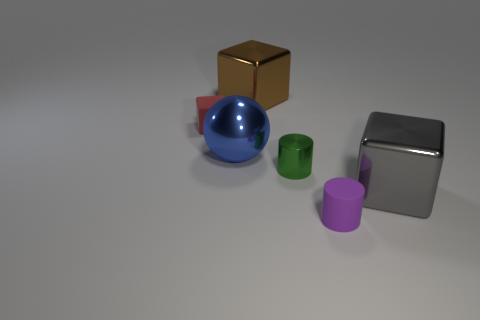How many other things are the same material as the tiny purple cylinder?
Keep it short and to the point. 1. The green shiny cylinder has what size?
Give a very brief answer. Small. Is there a big gray thing that has the same shape as the brown metallic object?
Keep it short and to the point. Yes. What number of objects are either blue shiny spheres or matte things behind the large gray cube?
Keep it short and to the point. 2. There is a big block behind the tiny block; what color is it?
Offer a terse response. Brown. Is the size of the cylinder that is on the left side of the small purple cylinder the same as the cube right of the green metallic object?
Keep it short and to the point. No. Is there a blue shiny sphere of the same size as the brown object?
Make the answer very short. Yes. How many big shiny things are on the right side of the matte thing behind the metallic ball?
Your response must be concise. 3. What is the big brown block made of?
Make the answer very short. Metal. What number of purple rubber things are on the right side of the gray metal thing?
Give a very brief answer. 0. 